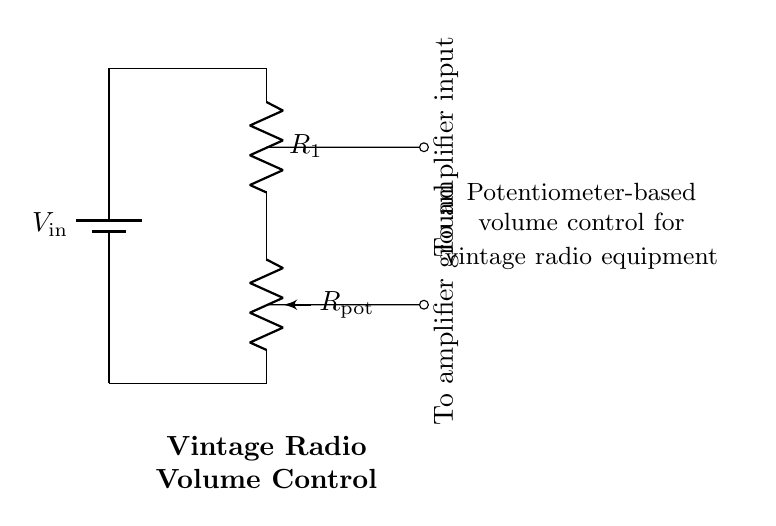What is the function of R1 in the circuit? R1 serves as a resistor in the voltage divider, influencing the voltage output from the potentiometer.
Answer: Resistor Which component adjusts the volume in this circuit? The potentiometer (Rpot) is the component that adjusts the output voltage level, effectively controlling the volume.
Answer: Potentiometer What type of circuit is shown in the diagram? The diagram represents a voltage divider circuit utilized for adjusting volume levels.
Answer: Voltage divider What is the direction of current flow in the circuit? The current flows from the positive terminal of the battery, through R1 and Rpot, and then returns to the battery's negative terminal.
Answer: Clockwise What is the purpose of the output connected to the amplifier input? The output provides a variable voltage signal that is sent to the amplifier for sound amplification based on the volume setting.
Answer: Volume control How many resistive components are present in the circuit? There are two resistive components: R1 and the potentiometer (Rpot).
Answer: Two What is the output purpose in a vintage radio? The output controls the audio signal level that goes to the amplifier, allowing the user to adjust the sound volume.
Answer: Volume adjustment 